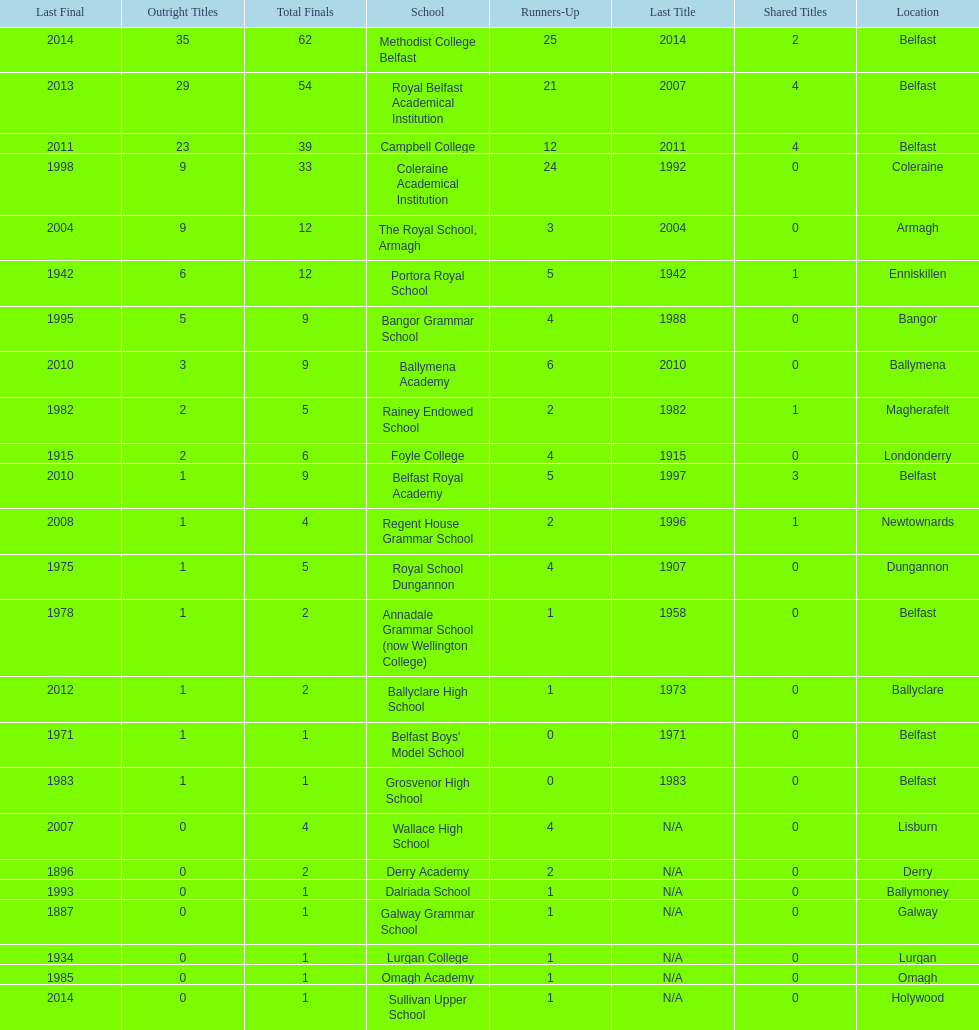What is the difference in runners-up from coleraine academical institution and royal school dungannon? 20. 